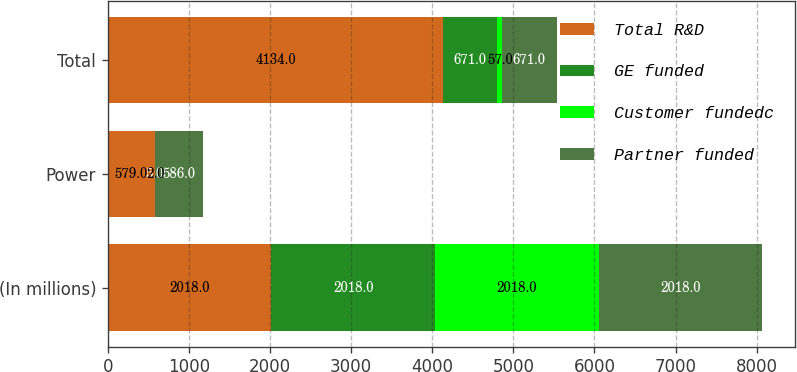Convert chart. <chart><loc_0><loc_0><loc_500><loc_500><stacked_bar_chart><ecel><fcel>(In millions)<fcel>Power<fcel>Total<nl><fcel>Total R&D<fcel>2018<fcel>579<fcel>4134<nl><fcel>GE funded<fcel>2018<fcel>5<fcel>671<nl><fcel>Customer fundedc<fcel>2018<fcel>2<fcel>57<nl><fcel>Partner funded<fcel>2018<fcel>586<fcel>671<nl></chart> 